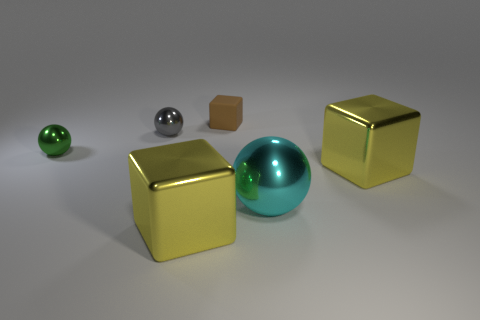Do the small metallic object that is right of the small green thing and the green metallic thing have the same shape?
Your response must be concise. Yes. Is there anything else that has the same size as the green thing?
Provide a short and direct response. Yes. Are there fewer tiny metal spheres left of the big cyan object than green metal things behind the small brown matte cube?
Offer a very short reply. No. How many other things are there of the same shape as the large cyan object?
Provide a succinct answer. 2. There is a cyan object on the right side of the large yellow metallic object in front of the big yellow metallic block right of the tiny brown thing; what size is it?
Provide a short and direct response. Large. What number of cyan objects are matte cubes or big objects?
Offer a very short reply. 1. What is the shape of the tiny metallic thing that is behind the object to the left of the small gray ball?
Provide a short and direct response. Sphere. There is a yellow metal thing that is in front of the large cyan metallic sphere; does it have the same size as the yellow cube on the right side of the large ball?
Offer a very short reply. Yes. Is there a cyan ball that has the same material as the cyan object?
Your answer should be compact. No. Are there any yellow metallic blocks in front of the yellow thing behind the sphere that is in front of the small green metallic thing?
Ensure brevity in your answer.  Yes. 